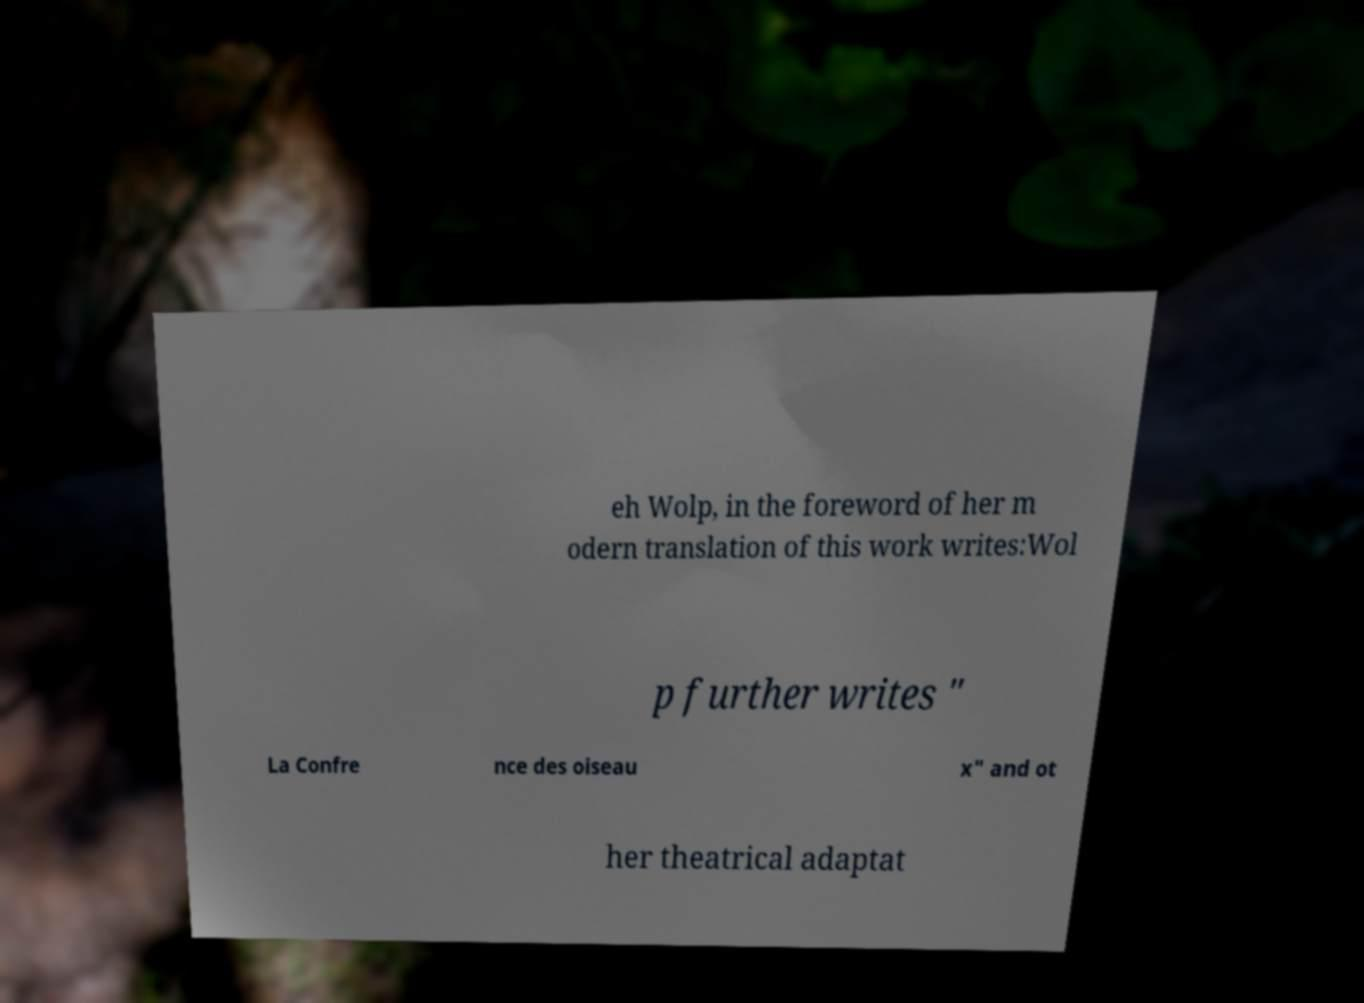Can you read and provide the text displayed in the image?This photo seems to have some interesting text. Can you extract and type it out for me? eh Wolp, in the foreword of her m odern translation of this work writes:Wol p further writes " La Confre nce des oiseau x" and ot her theatrical adaptat 